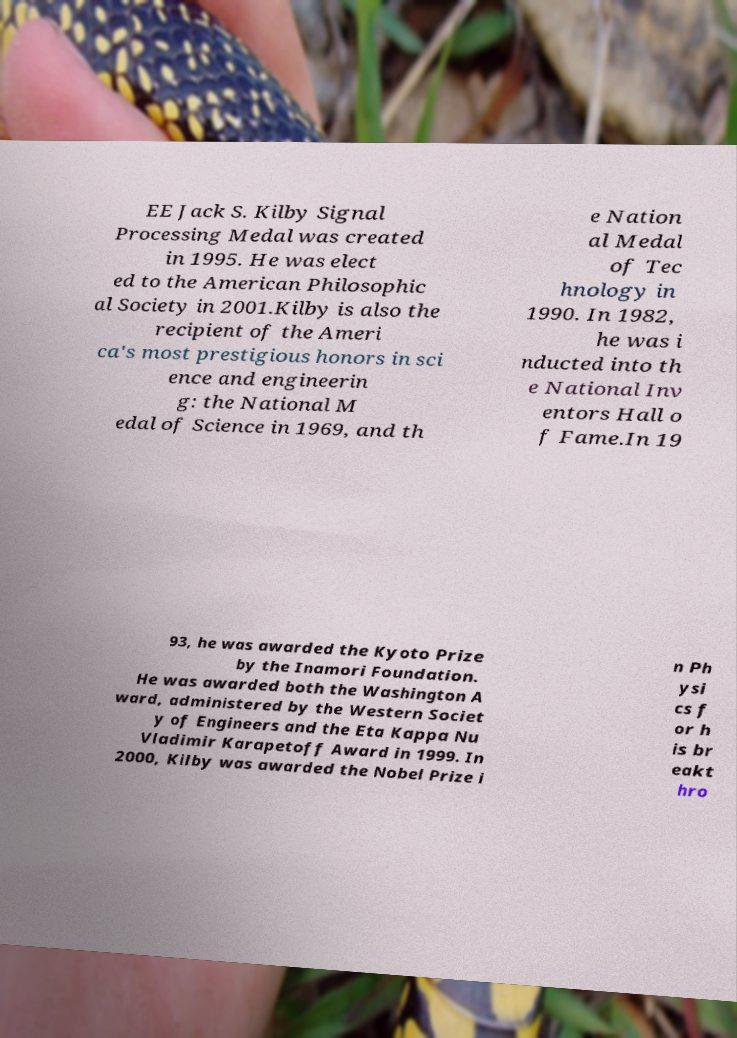I need the written content from this picture converted into text. Can you do that? EE Jack S. Kilby Signal Processing Medal was created in 1995. He was elect ed to the American Philosophic al Society in 2001.Kilby is also the recipient of the Ameri ca's most prestigious honors in sci ence and engineerin g: the National M edal of Science in 1969, and th e Nation al Medal of Tec hnology in 1990. In 1982, he was i nducted into th e National Inv entors Hall o f Fame.In 19 93, he was awarded the Kyoto Prize by the Inamori Foundation. He was awarded both the Washington A ward, administered by the Western Societ y of Engineers and the Eta Kappa Nu Vladimir Karapetoff Award in 1999. In 2000, Kilby was awarded the Nobel Prize i n Ph ysi cs f or h is br eakt hro 